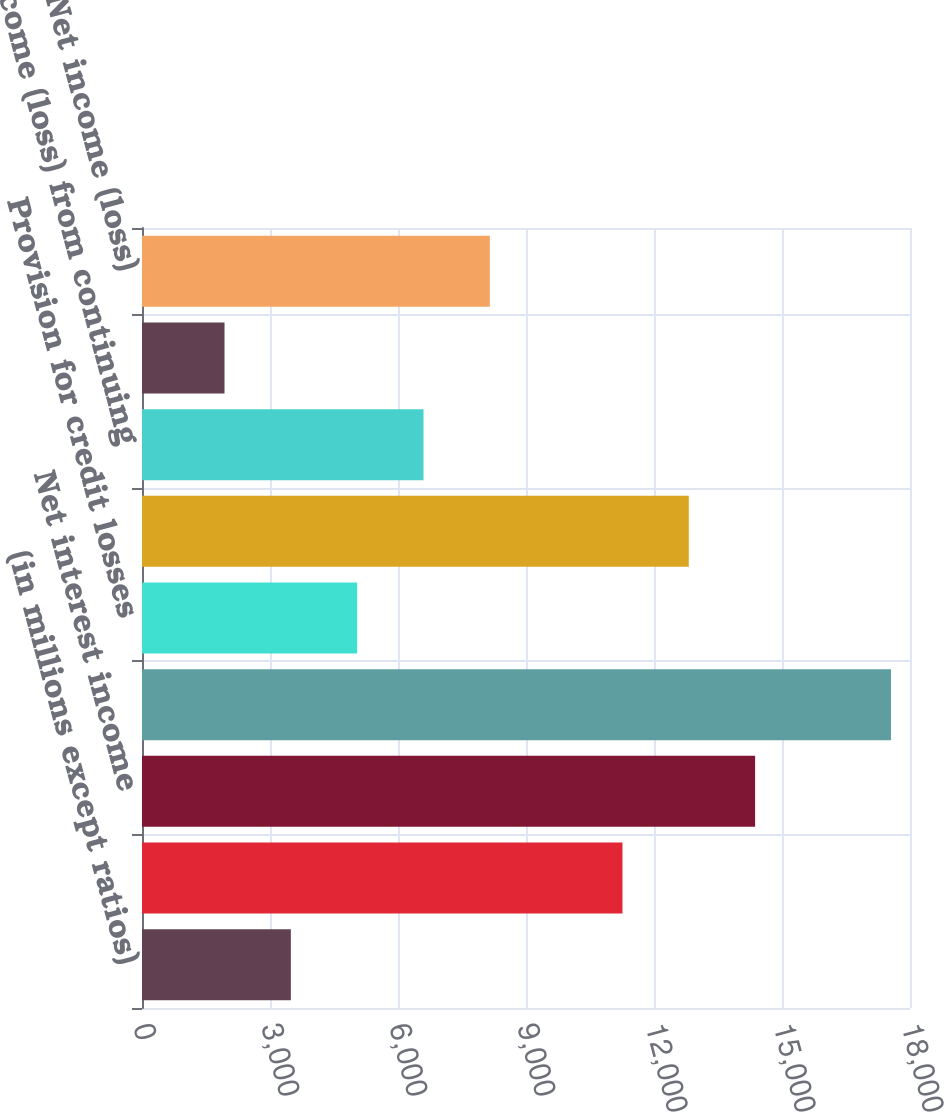Convert chart. <chart><loc_0><loc_0><loc_500><loc_500><bar_chart><fcel>(in millions except ratios)<fcel>Noninter est revenue<fcel>Net interest income<fcel>T otal net revenue<fcel>Provision for credit losses<fcel>Noninterest expense (c)<fcel>Income (loss) from continuing<fcel>Income tax expense (benefit)<fcel>Net income (loss)<nl><fcel>3488.5<fcel>11261<fcel>14370<fcel>17554.5<fcel>5043<fcel>12815.5<fcel>6597.5<fcel>1934<fcel>8152<nl></chart> 